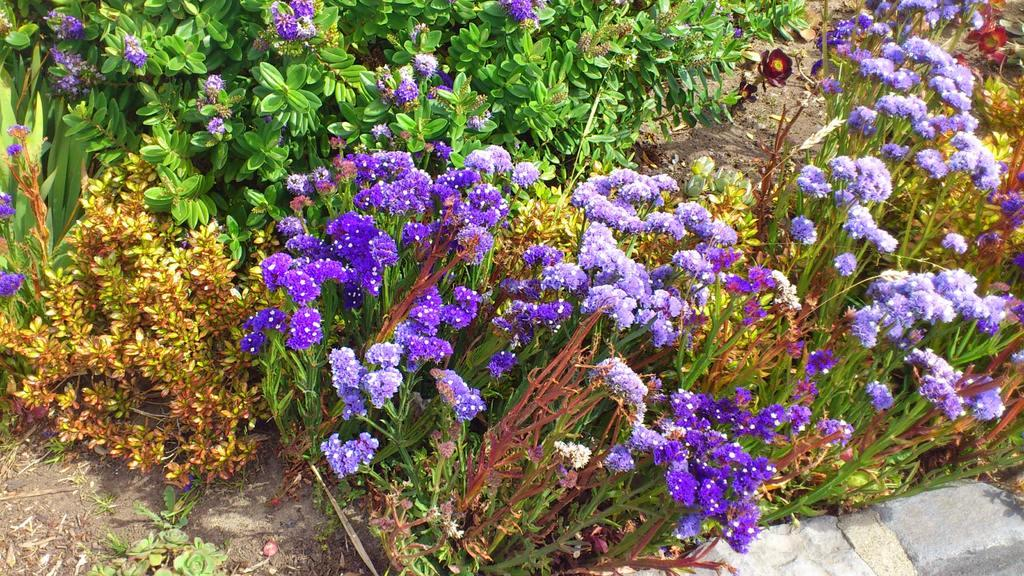What types of living organisms can be seen in the image? There are different types of plants in the image. What specific features can be observed on the plants? There are flowers in the image. What colors are the flowers? The flowers are in purple and maroon colors. Is there any architectural element visible in the image? Yes, there is a wall in the bottom right corner of the image. Where is the lunchroom located in the image? There is no lunchroom present in the image. What type of box can be seen in the image? There is no box present in the image. 